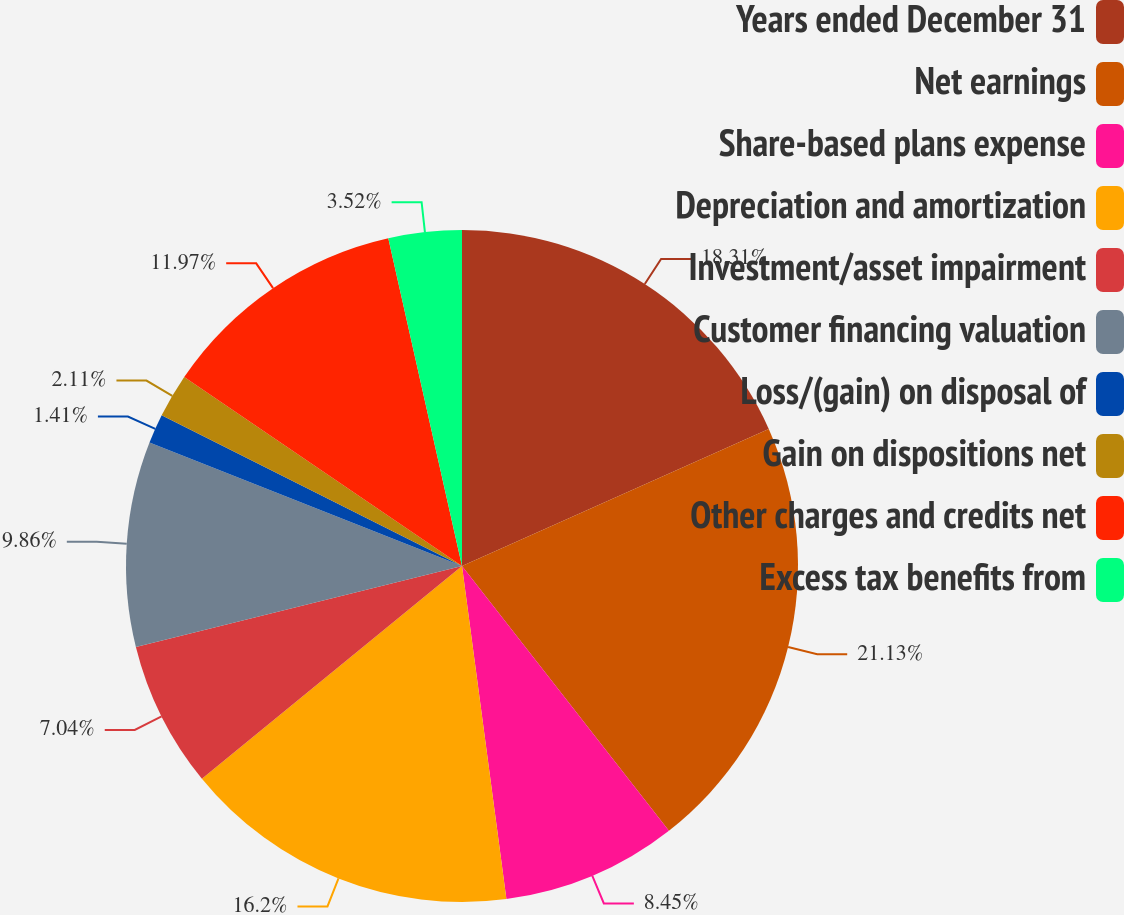Convert chart to OTSL. <chart><loc_0><loc_0><loc_500><loc_500><pie_chart><fcel>Years ended December 31<fcel>Net earnings<fcel>Share-based plans expense<fcel>Depreciation and amortization<fcel>Investment/asset impairment<fcel>Customer financing valuation<fcel>Loss/(gain) on disposal of<fcel>Gain on dispositions net<fcel>Other charges and credits net<fcel>Excess tax benefits from<nl><fcel>18.31%<fcel>21.13%<fcel>8.45%<fcel>16.2%<fcel>7.04%<fcel>9.86%<fcel>1.41%<fcel>2.11%<fcel>11.97%<fcel>3.52%<nl></chart> 